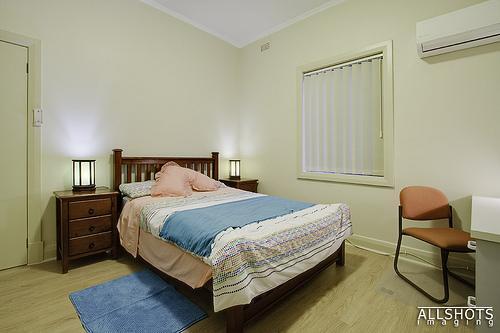How many beds are there?
Give a very brief answer. 1. 